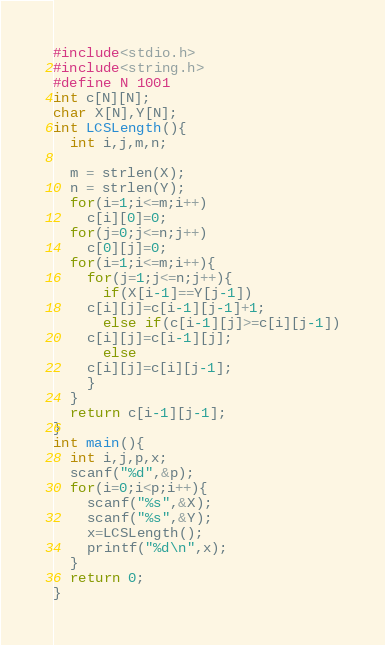<code> <loc_0><loc_0><loc_500><loc_500><_C_>#include<stdio.h>
#include<string.h>
#define N 1001
int c[N][N];
char X[N],Y[N];
int LCSLength(){
  int i,j,m,n;

  m = strlen(X);
  n = strlen(Y);
  for(i=1;i<=m;i++)
    c[i][0]=0;
  for(j=0;j<=n;j++)
    c[0][j]=0;
  for(i=1;i<=m;i++){
    for(j=1;j<=n;j++){
      if(X[i-1]==Y[j-1])
	c[i][j]=c[i-1][j-1]+1;
      else if(c[i-1][j]>=c[i][j-1])
	c[i][j]=c[i-1][j];
      else
	c[i][j]=c[i][j-1];
    }
  }
  return c[i-1][j-1];  
}
int main(){
  int i,j,p,x;
  scanf("%d",&p);
  for(i=0;i<p;i++){
    scanf("%s",&X);
    scanf("%s",&Y);
    x=LCSLength();
    printf("%d\n",x);
  }
  return 0;
}</code> 